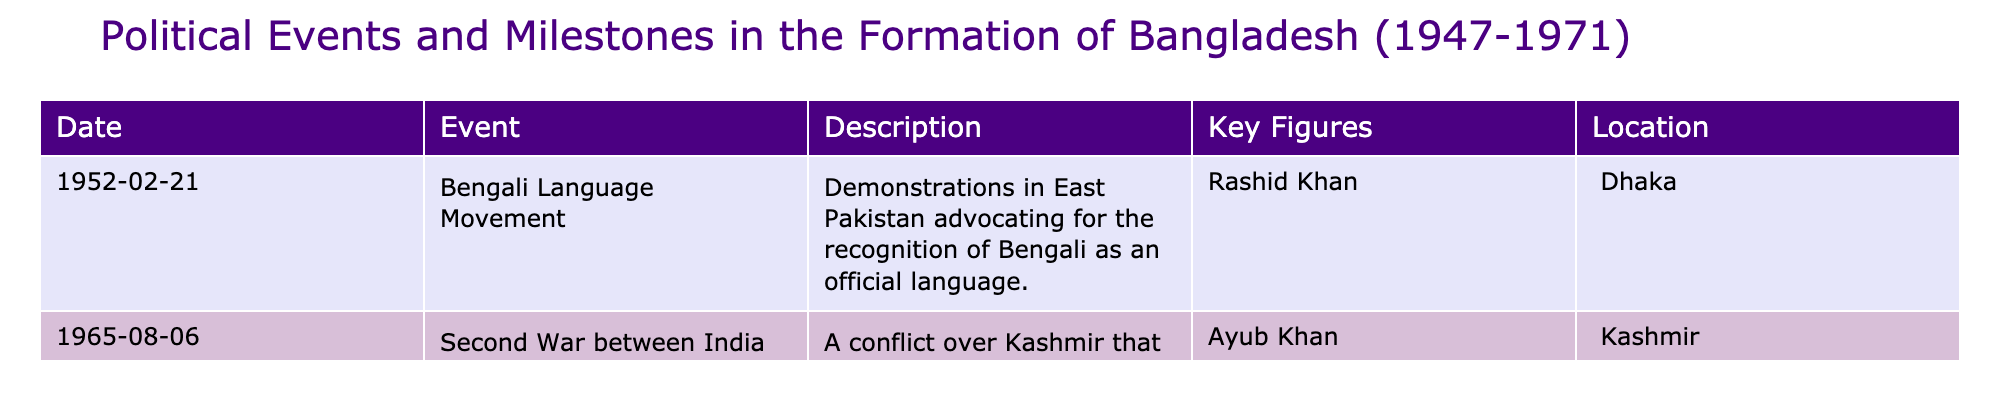What event is associated with February 21, 1952? The table indicates that on February 21, 1952, the "Bengali Language Movement" occurred, which involved demonstrations advocating for the recognition of Bengali as an official language.
Answer: Bengali Language Movement Who was a key figure in the Bengali Language Movement? The table lists Rashid Khan as a key figure in the Bengali Language Movement, which took place in Dhaka on February 21, 1952.
Answer: Rashid Khan What was the location of the Second War between India and Pakistan? According to the table, the Second War between India and Pakistan occurred in Kashmir.
Answer: Kashmir How many events are listed in the table? The table shows a total of two events listed, which are the Bengali Language Movement and the Second War between India and Pakistan.
Answer: 2 True or False: The Bengali Language Movement took place in 1952. The date for the Bengali Language Movement in the table clearly shows it occurred on February 21, 1952, making the statement true.
Answer: True What is the difference in years between the Bengali Language Movement and the Second War between India and Pakistan? The Bengali Language Movement occurred in 1952 and the Second War in 1965. The difference is 1965 - 1952 = 13 years.
Answer: 13 years List all key figures mentioned in the table. The table mentions two key figures: Rashid Khan associated with the Bengali Language Movement and Ayub Khan related to the Second War between India and Pakistan.
Answer: Rashid Khan, Ayub Khan Which event occurred first and what events took place after that? The Bengali Language Movement occurred first in 1952, followed by the Second War between India and Pakistan in 1965.
Answer: Bengali Language Movement, Second War between India and Pakistan What percentage of the events in the table are directly related to language advocacy? There is one event related to language advocacy (Bengali Language Movement) out of two events total, which is (1/2) * 100 = 50%.
Answer: 50% Identify a political event that occurred in the mid-1960s and describe its significance. The Second War between India and Pakistan in 1965 is a key event from the mid-1960s that further strained relations between East and West Pakistan, highlighting significant political differences.
Answer: Second War between India and Pakistan, significant for strained relations 